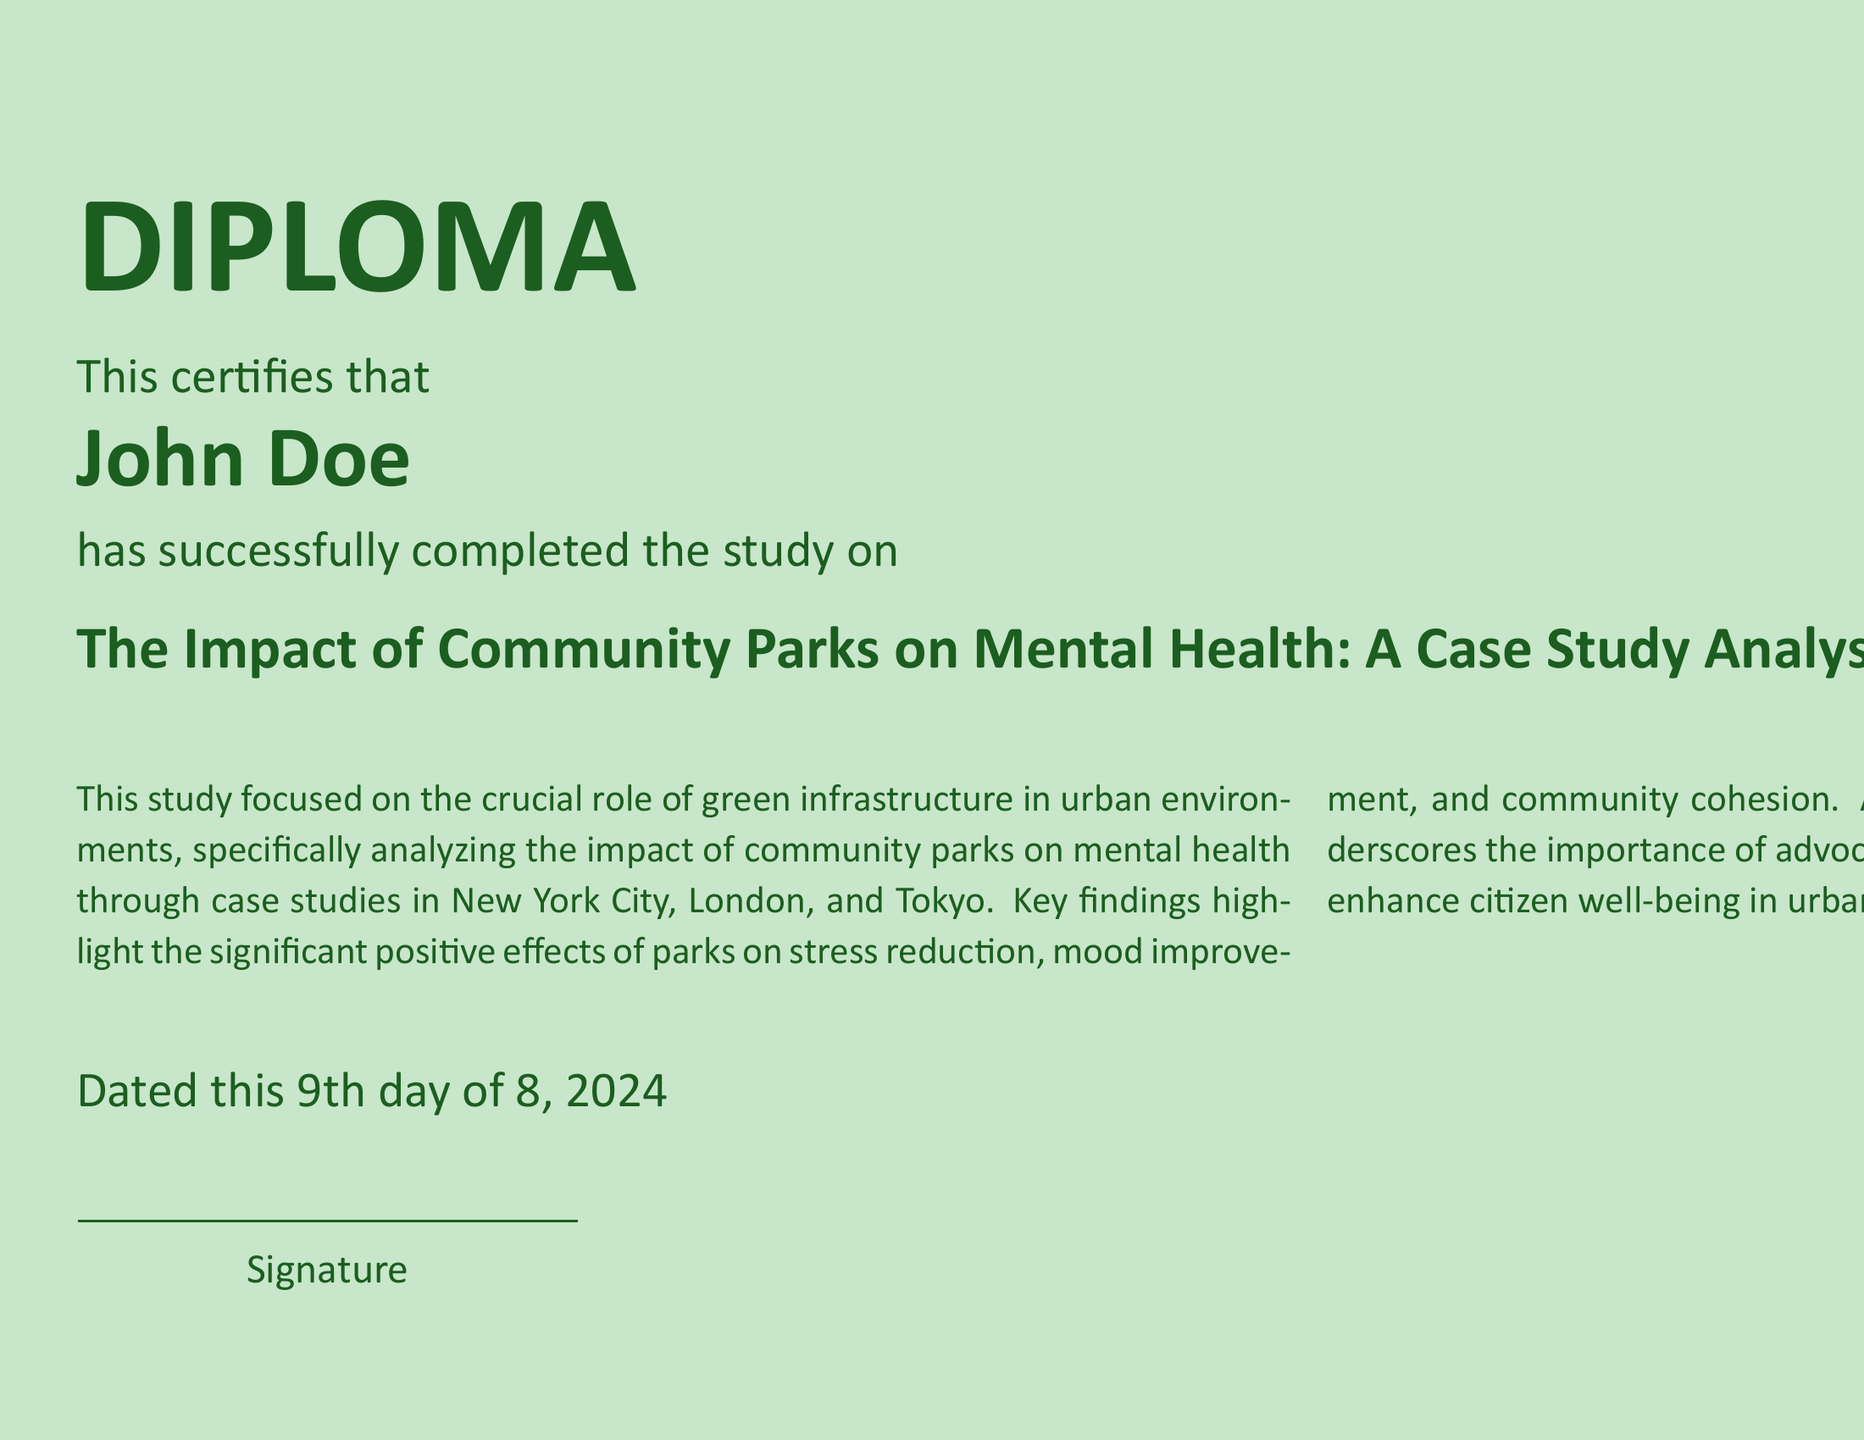What is the title of the study? The title of the study is prominently displayed in the document and reads "The Impact of Community Parks on Mental Health: A Case Study Analysis of Urban Areas."
Answer: The Impact of Community Parks on Mental Health: A Case Study Analysis of Urban Areas Who is the person certified by the diploma? The diploma certifies an individual who has completed the study, and their name is clearly stated in the document.
Answer: John Doe Which cities are analyzed in the study? The document mentions specific cities where the case studies were conducted to analyze the impact of community parks on mental health.
Answer: New York City, London, Tokyo What positive effects of parks are highlighted in the study? The document's summary discusses key findings regarding the impact of community parks, which include various mental health benefits.
Answer: Stress reduction, mood improvement, community cohesion What role does the research underscore for public health officers? The document suggests a specific advocacy role for public health officers concerning urban green spaces, indicating the importance of their involvement.
Answer: Advocating for and implementing green spaces 